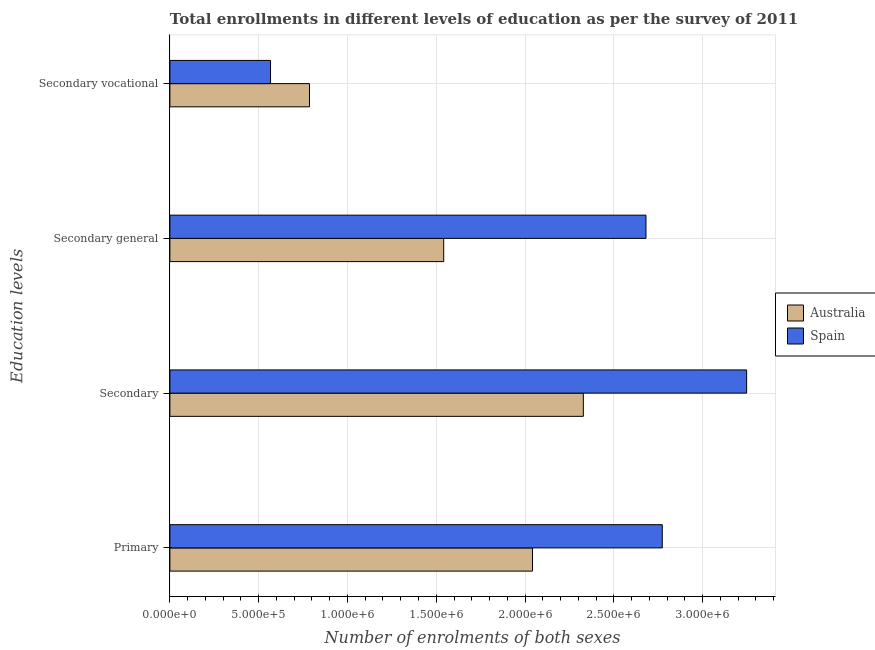How many different coloured bars are there?
Provide a succinct answer. 2. How many groups of bars are there?
Make the answer very short. 4. Are the number of bars on each tick of the Y-axis equal?
Your response must be concise. Yes. How many bars are there on the 1st tick from the bottom?
Make the answer very short. 2. What is the label of the 3rd group of bars from the top?
Provide a short and direct response. Secondary. What is the number of enrolments in secondary education in Spain?
Make the answer very short. 3.25e+06. Across all countries, what is the maximum number of enrolments in secondary vocational education?
Offer a very short reply. 7.86e+05. Across all countries, what is the minimum number of enrolments in secondary general education?
Provide a short and direct response. 1.54e+06. In which country was the number of enrolments in secondary education minimum?
Offer a very short reply. Australia. What is the total number of enrolments in secondary vocational education in the graph?
Offer a very short reply. 1.35e+06. What is the difference between the number of enrolments in secondary general education in Australia and that in Spain?
Give a very brief answer. -1.14e+06. What is the difference between the number of enrolments in secondary general education in Australia and the number of enrolments in secondary education in Spain?
Offer a very short reply. -1.71e+06. What is the average number of enrolments in secondary general education per country?
Provide a short and direct response. 2.11e+06. What is the difference between the number of enrolments in primary education and number of enrolments in secondary vocational education in Australia?
Make the answer very short. 1.26e+06. In how many countries, is the number of enrolments in secondary vocational education greater than 2400000 ?
Offer a terse response. 0. What is the ratio of the number of enrolments in primary education in Australia to that in Spain?
Keep it short and to the point. 0.74. Is the number of enrolments in secondary education in Australia less than that in Spain?
Offer a very short reply. Yes. What is the difference between the highest and the second highest number of enrolments in secondary education?
Your answer should be very brief. 9.20e+05. What is the difference between the highest and the lowest number of enrolments in secondary vocational education?
Your answer should be compact. 2.19e+05. What does the 2nd bar from the top in Primary represents?
Offer a very short reply. Australia. What does the 1st bar from the bottom in Secondary vocational represents?
Provide a short and direct response. Australia. Is it the case that in every country, the sum of the number of enrolments in primary education and number of enrolments in secondary education is greater than the number of enrolments in secondary general education?
Your answer should be compact. Yes. How many bars are there?
Offer a terse response. 8. How many countries are there in the graph?
Offer a terse response. 2. What is the difference between two consecutive major ticks on the X-axis?
Your answer should be compact. 5.00e+05. Does the graph contain grids?
Offer a very short reply. Yes. Where does the legend appear in the graph?
Give a very brief answer. Center right. How are the legend labels stacked?
Offer a very short reply. Vertical. What is the title of the graph?
Ensure brevity in your answer.  Total enrollments in different levels of education as per the survey of 2011. What is the label or title of the X-axis?
Keep it short and to the point. Number of enrolments of both sexes. What is the label or title of the Y-axis?
Ensure brevity in your answer.  Education levels. What is the Number of enrolments of both sexes in Australia in Primary?
Provide a succinct answer. 2.04e+06. What is the Number of enrolments of both sexes of Spain in Primary?
Keep it short and to the point. 2.77e+06. What is the Number of enrolments of both sexes of Australia in Secondary?
Make the answer very short. 2.33e+06. What is the Number of enrolments of both sexes in Spain in Secondary?
Keep it short and to the point. 3.25e+06. What is the Number of enrolments of both sexes in Australia in Secondary general?
Your response must be concise. 1.54e+06. What is the Number of enrolments of both sexes of Spain in Secondary general?
Keep it short and to the point. 2.68e+06. What is the Number of enrolments of both sexes of Australia in Secondary vocational?
Keep it short and to the point. 7.86e+05. What is the Number of enrolments of both sexes in Spain in Secondary vocational?
Make the answer very short. 5.67e+05. Across all Education levels, what is the maximum Number of enrolments of both sexes of Australia?
Provide a short and direct response. 2.33e+06. Across all Education levels, what is the maximum Number of enrolments of both sexes in Spain?
Your response must be concise. 3.25e+06. Across all Education levels, what is the minimum Number of enrolments of both sexes of Australia?
Offer a very short reply. 7.86e+05. Across all Education levels, what is the minimum Number of enrolments of both sexes in Spain?
Provide a short and direct response. 5.67e+05. What is the total Number of enrolments of both sexes of Australia in the graph?
Offer a terse response. 6.70e+06. What is the total Number of enrolments of both sexes in Spain in the graph?
Make the answer very short. 9.27e+06. What is the difference between the Number of enrolments of both sexes of Australia in Primary and that in Secondary?
Offer a terse response. -2.86e+05. What is the difference between the Number of enrolments of both sexes in Spain in Primary and that in Secondary?
Your response must be concise. -4.75e+05. What is the difference between the Number of enrolments of both sexes of Australia in Primary and that in Secondary general?
Offer a very short reply. 5.00e+05. What is the difference between the Number of enrolments of both sexes of Spain in Primary and that in Secondary general?
Offer a very short reply. 9.17e+04. What is the difference between the Number of enrolments of both sexes of Australia in Primary and that in Secondary vocational?
Your answer should be very brief. 1.26e+06. What is the difference between the Number of enrolments of both sexes of Spain in Primary and that in Secondary vocational?
Provide a short and direct response. 2.21e+06. What is the difference between the Number of enrolments of both sexes in Australia in Secondary and that in Secondary general?
Keep it short and to the point. 7.86e+05. What is the difference between the Number of enrolments of both sexes in Spain in Secondary and that in Secondary general?
Give a very brief answer. 5.67e+05. What is the difference between the Number of enrolments of both sexes in Australia in Secondary and that in Secondary vocational?
Offer a terse response. 1.54e+06. What is the difference between the Number of enrolments of both sexes of Spain in Secondary and that in Secondary vocational?
Your answer should be very brief. 2.68e+06. What is the difference between the Number of enrolments of both sexes of Australia in Secondary general and that in Secondary vocational?
Give a very brief answer. 7.56e+05. What is the difference between the Number of enrolments of both sexes of Spain in Secondary general and that in Secondary vocational?
Give a very brief answer. 2.11e+06. What is the difference between the Number of enrolments of both sexes in Australia in Primary and the Number of enrolments of both sexes in Spain in Secondary?
Provide a succinct answer. -1.21e+06. What is the difference between the Number of enrolments of both sexes in Australia in Primary and the Number of enrolments of both sexes in Spain in Secondary general?
Offer a very short reply. -6.39e+05. What is the difference between the Number of enrolments of both sexes in Australia in Primary and the Number of enrolments of both sexes in Spain in Secondary vocational?
Make the answer very short. 1.48e+06. What is the difference between the Number of enrolments of both sexes of Australia in Secondary and the Number of enrolments of both sexes of Spain in Secondary general?
Offer a terse response. -3.53e+05. What is the difference between the Number of enrolments of both sexes in Australia in Secondary and the Number of enrolments of both sexes in Spain in Secondary vocational?
Keep it short and to the point. 1.76e+06. What is the difference between the Number of enrolments of both sexes in Australia in Secondary general and the Number of enrolments of both sexes in Spain in Secondary vocational?
Make the answer very short. 9.75e+05. What is the average Number of enrolments of both sexes of Australia per Education levels?
Provide a succinct answer. 1.67e+06. What is the average Number of enrolments of both sexes in Spain per Education levels?
Make the answer very short. 2.32e+06. What is the difference between the Number of enrolments of both sexes of Australia and Number of enrolments of both sexes of Spain in Primary?
Provide a succinct answer. -7.31e+05. What is the difference between the Number of enrolments of both sexes of Australia and Number of enrolments of both sexes of Spain in Secondary?
Your response must be concise. -9.20e+05. What is the difference between the Number of enrolments of both sexes in Australia and Number of enrolments of both sexes in Spain in Secondary general?
Provide a short and direct response. -1.14e+06. What is the difference between the Number of enrolments of both sexes of Australia and Number of enrolments of both sexes of Spain in Secondary vocational?
Offer a very short reply. 2.19e+05. What is the ratio of the Number of enrolments of both sexes in Australia in Primary to that in Secondary?
Your answer should be compact. 0.88. What is the ratio of the Number of enrolments of both sexes in Spain in Primary to that in Secondary?
Offer a terse response. 0.85. What is the ratio of the Number of enrolments of both sexes of Australia in Primary to that in Secondary general?
Keep it short and to the point. 1.32. What is the ratio of the Number of enrolments of both sexes in Spain in Primary to that in Secondary general?
Make the answer very short. 1.03. What is the ratio of the Number of enrolments of both sexes of Australia in Primary to that in Secondary vocational?
Offer a very short reply. 2.6. What is the ratio of the Number of enrolments of both sexes in Spain in Primary to that in Secondary vocational?
Your response must be concise. 4.89. What is the ratio of the Number of enrolments of both sexes in Australia in Secondary to that in Secondary general?
Give a very brief answer. 1.51. What is the ratio of the Number of enrolments of both sexes in Spain in Secondary to that in Secondary general?
Offer a very short reply. 1.21. What is the ratio of the Number of enrolments of both sexes of Australia in Secondary to that in Secondary vocational?
Offer a very short reply. 2.96. What is the ratio of the Number of enrolments of both sexes in Spain in Secondary to that in Secondary vocational?
Keep it short and to the point. 5.73. What is the ratio of the Number of enrolments of both sexes of Australia in Secondary general to that in Secondary vocational?
Your answer should be compact. 1.96. What is the ratio of the Number of enrolments of both sexes of Spain in Secondary general to that in Secondary vocational?
Provide a short and direct response. 4.73. What is the difference between the highest and the second highest Number of enrolments of both sexes in Australia?
Your answer should be very brief. 2.86e+05. What is the difference between the highest and the second highest Number of enrolments of both sexes in Spain?
Your answer should be very brief. 4.75e+05. What is the difference between the highest and the lowest Number of enrolments of both sexes of Australia?
Offer a very short reply. 1.54e+06. What is the difference between the highest and the lowest Number of enrolments of both sexes of Spain?
Give a very brief answer. 2.68e+06. 